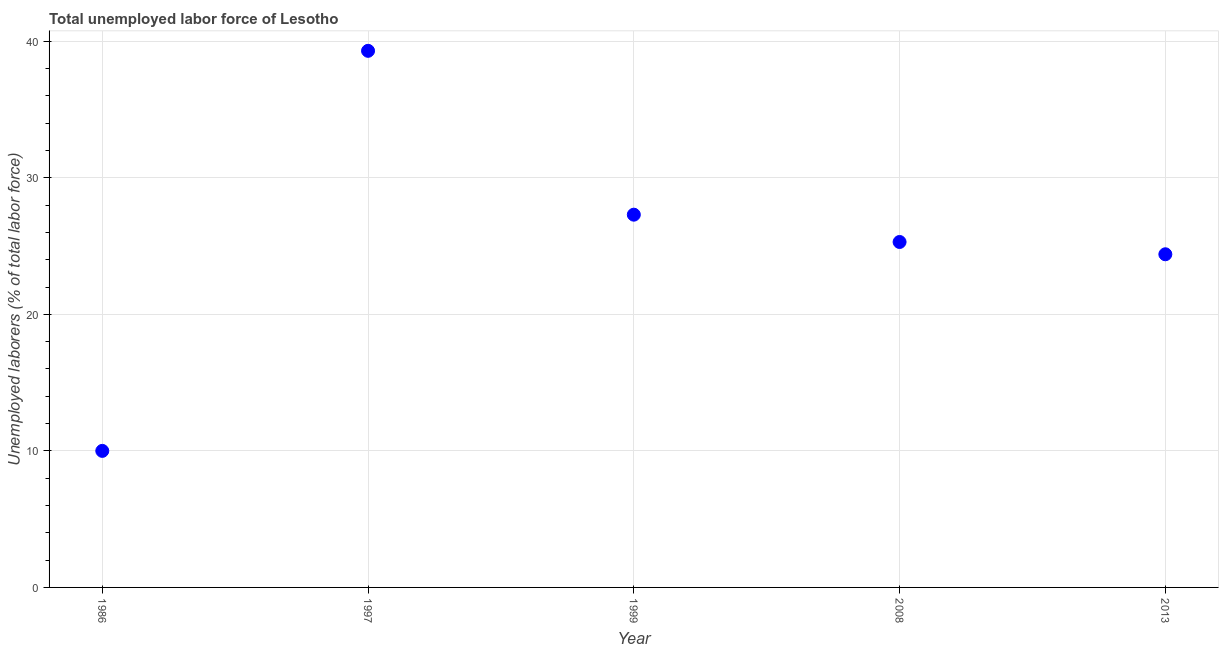What is the total unemployed labour force in 1999?
Your response must be concise. 27.3. Across all years, what is the maximum total unemployed labour force?
Offer a very short reply. 39.3. What is the sum of the total unemployed labour force?
Make the answer very short. 126.3. What is the difference between the total unemployed labour force in 2008 and 2013?
Keep it short and to the point. 0.9. What is the average total unemployed labour force per year?
Offer a very short reply. 25.26. What is the median total unemployed labour force?
Offer a terse response. 25.3. Do a majority of the years between 1986 and 2008 (inclusive) have total unemployed labour force greater than 38 %?
Offer a very short reply. No. What is the ratio of the total unemployed labour force in 1986 to that in 2008?
Your response must be concise. 0.4. Is the total unemployed labour force in 1997 less than that in 2013?
Provide a succinct answer. No. Is the difference between the total unemployed labour force in 1986 and 2013 greater than the difference between any two years?
Your answer should be very brief. No. What is the difference between the highest and the second highest total unemployed labour force?
Offer a terse response. 12. Is the sum of the total unemployed labour force in 2008 and 2013 greater than the maximum total unemployed labour force across all years?
Give a very brief answer. Yes. What is the difference between the highest and the lowest total unemployed labour force?
Your response must be concise. 29.3. In how many years, is the total unemployed labour force greater than the average total unemployed labour force taken over all years?
Your answer should be compact. 3. Does the total unemployed labour force monotonically increase over the years?
Offer a terse response. No. How many dotlines are there?
Ensure brevity in your answer.  1. How many years are there in the graph?
Offer a very short reply. 5. Does the graph contain any zero values?
Provide a succinct answer. No. What is the title of the graph?
Offer a terse response. Total unemployed labor force of Lesotho. What is the label or title of the X-axis?
Offer a terse response. Year. What is the label or title of the Y-axis?
Offer a very short reply. Unemployed laborers (% of total labor force). What is the Unemployed laborers (% of total labor force) in 1986?
Provide a short and direct response. 10. What is the Unemployed laborers (% of total labor force) in 1997?
Provide a succinct answer. 39.3. What is the Unemployed laborers (% of total labor force) in 1999?
Keep it short and to the point. 27.3. What is the Unemployed laborers (% of total labor force) in 2008?
Provide a succinct answer. 25.3. What is the Unemployed laborers (% of total labor force) in 2013?
Make the answer very short. 24.4. What is the difference between the Unemployed laborers (% of total labor force) in 1986 and 1997?
Make the answer very short. -29.3. What is the difference between the Unemployed laborers (% of total labor force) in 1986 and 1999?
Offer a very short reply. -17.3. What is the difference between the Unemployed laborers (% of total labor force) in 1986 and 2008?
Provide a short and direct response. -15.3. What is the difference between the Unemployed laborers (% of total labor force) in 1986 and 2013?
Ensure brevity in your answer.  -14.4. What is the difference between the Unemployed laborers (% of total labor force) in 1997 and 1999?
Give a very brief answer. 12. What is the difference between the Unemployed laborers (% of total labor force) in 1997 and 2008?
Offer a terse response. 14. What is the difference between the Unemployed laborers (% of total labor force) in 1997 and 2013?
Provide a short and direct response. 14.9. What is the difference between the Unemployed laborers (% of total labor force) in 2008 and 2013?
Keep it short and to the point. 0.9. What is the ratio of the Unemployed laborers (% of total labor force) in 1986 to that in 1997?
Ensure brevity in your answer.  0.25. What is the ratio of the Unemployed laborers (% of total labor force) in 1986 to that in 1999?
Make the answer very short. 0.37. What is the ratio of the Unemployed laborers (% of total labor force) in 1986 to that in 2008?
Your response must be concise. 0.4. What is the ratio of the Unemployed laborers (% of total labor force) in 1986 to that in 2013?
Keep it short and to the point. 0.41. What is the ratio of the Unemployed laborers (% of total labor force) in 1997 to that in 1999?
Make the answer very short. 1.44. What is the ratio of the Unemployed laborers (% of total labor force) in 1997 to that in 2008?
Offer a very short reply. 1.55. What is the ratio of the Unemployed laborers (% of total labor force) in 1997 to that in 2013?
Make the answer very short. 1.61. What is the ratio of the Unemployed laborers (% of total labor force) in 1999 to that in 2008?
Offer a terse response. 1.08. What is the ratio of the Unemployed laborers (% of total labor force) in 1999 to that in 2013?
Your answer should be compact. 1.12. What is the ratio of the Unemployed laborers (% of total labor force) in 2008 to that in 2013?
Keep it short and to the point. 1.04. 